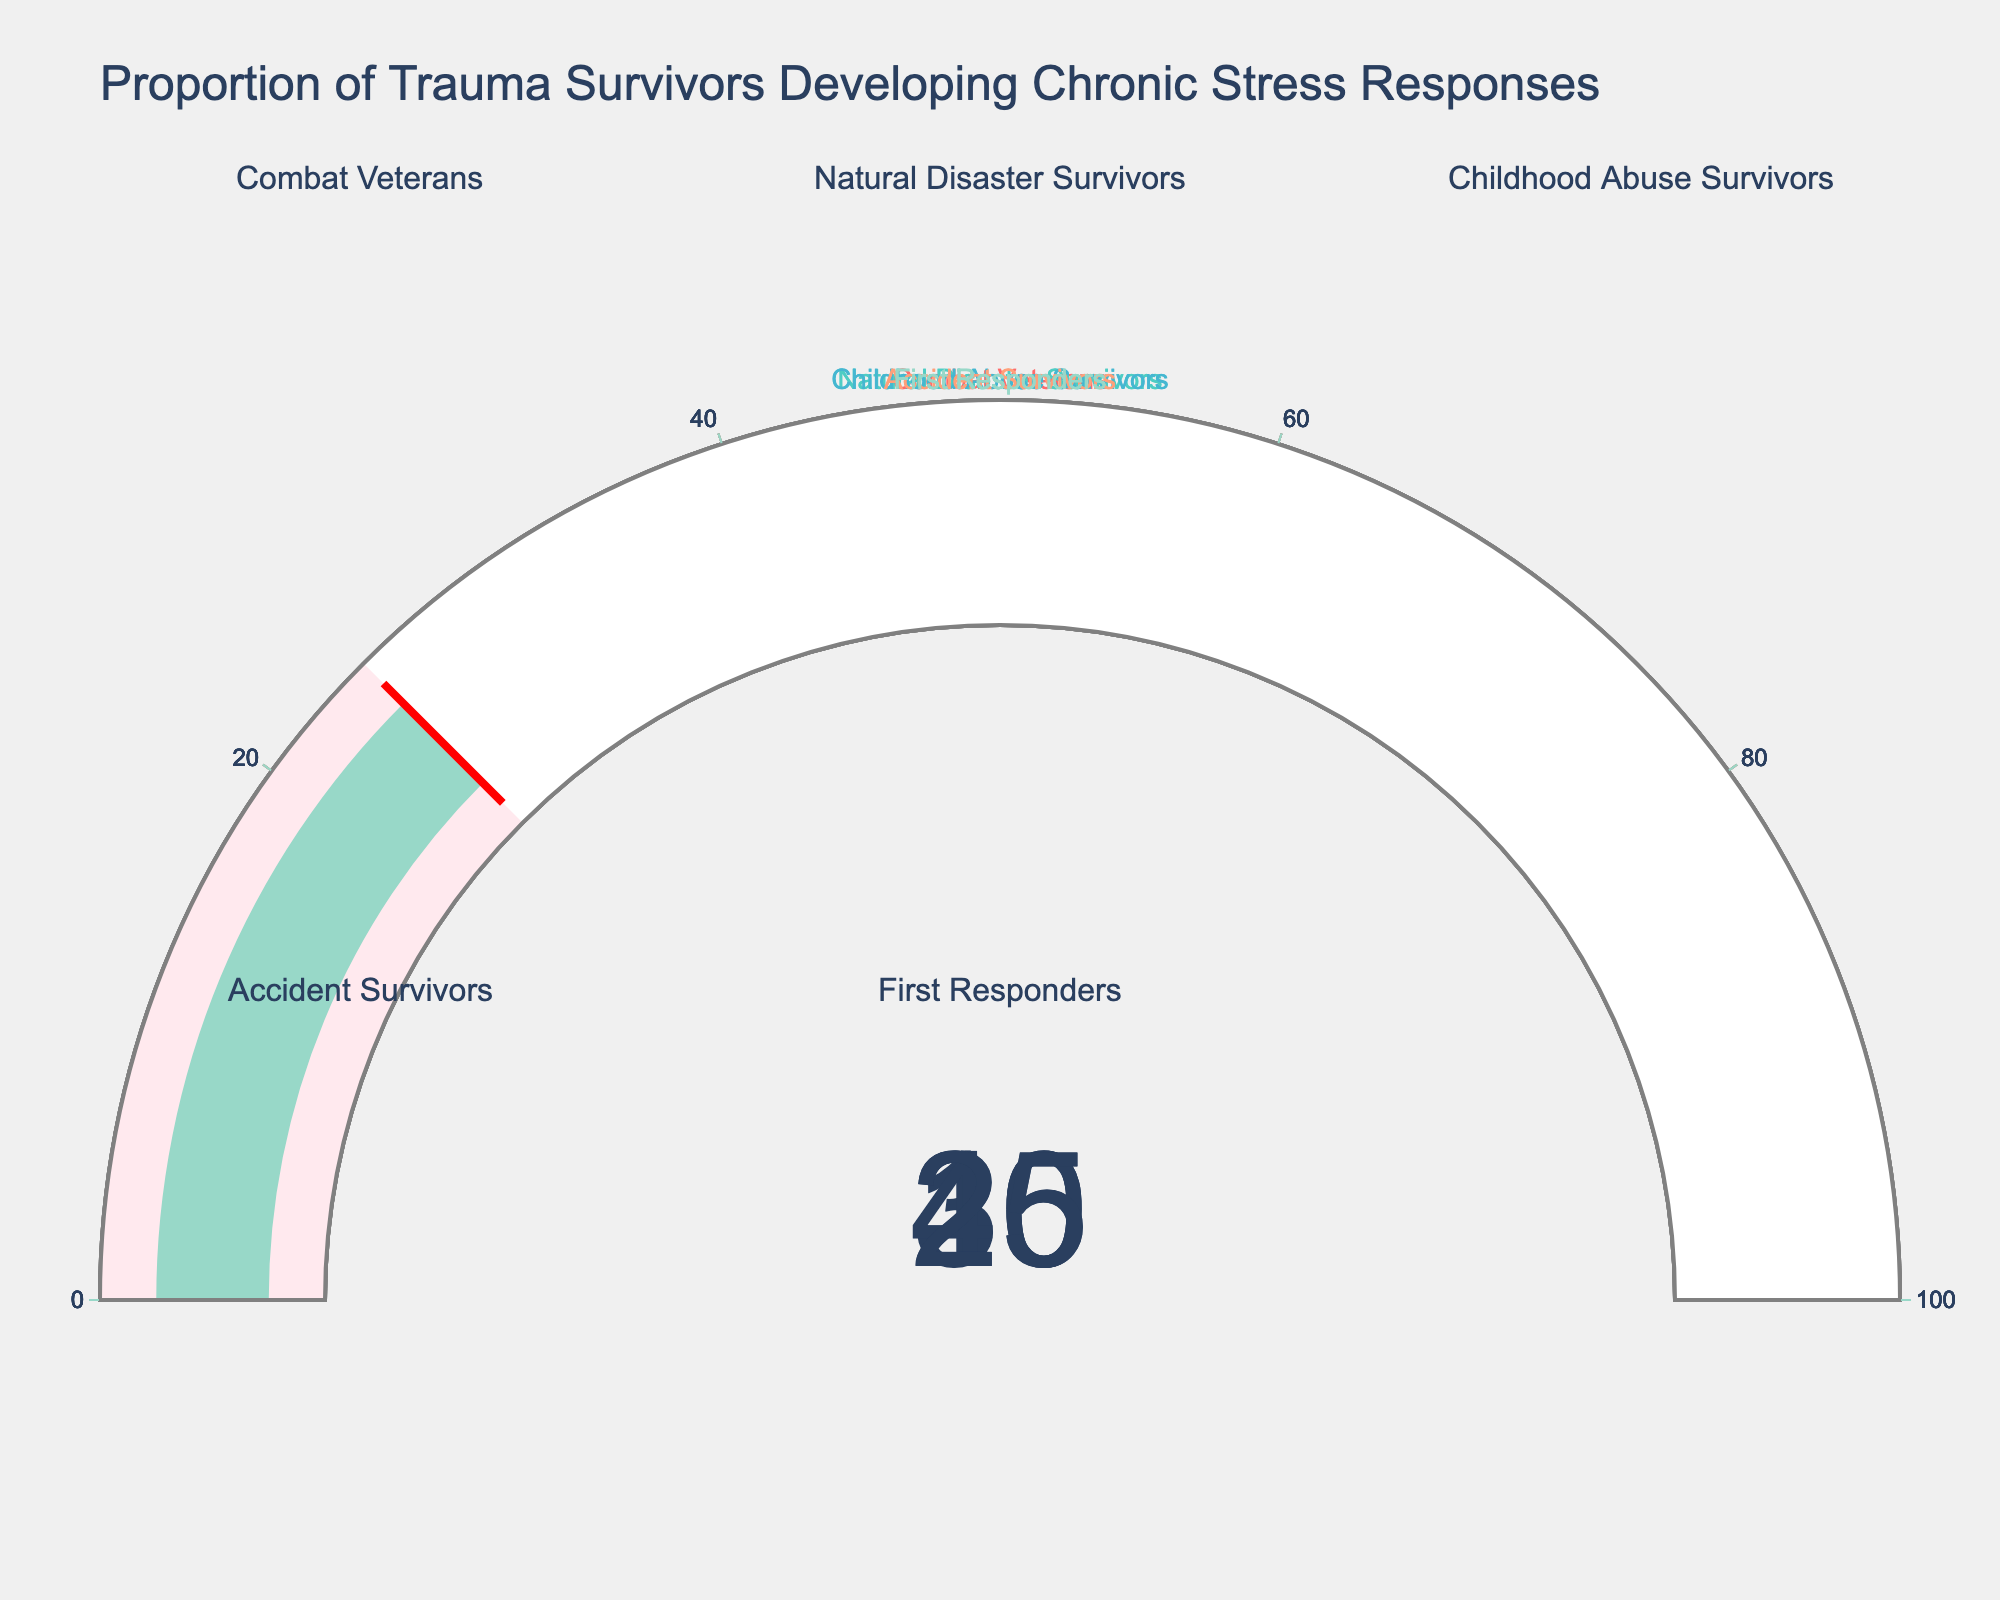What is the title of the figure? The title is located at the top of the figure and provides an overall description of the content. By reading the title text, we can identify it.
Answer: Proportion of Trauma Survivors Developing Chronic Stress Responses How many categories are displayed in the figure? By counting the number of individual gauge charts in the figure, we can determine the number of categories.
Answer: 5 Which category has the highest proportion of trauma survivors developing chronic stress responses? To find this, we compare the values displayed on each gauge chart. The highest value will indicate the category with the highest proportion.
Answer: Childhood Abuse Survivors What is the difference in percentage between Accident Survivors and First Responders? Identify the values for Accident Survivors (20%) and First Responders (25%). Subtract the smaller percentage from the larger one to find the difference.
Answer: 5% Which category has a lower proportion of chronic stress responses, Natural Disaster Survivors or Combat Veterans? By comparing the values for Natural Disaster Survivors (15%) and Combat Veterans (30%), we can see which is lower.
Answer: Natural Disaster Survivors Calculate the average proportion of chronic stress responses across all categories. Sum the percentages (30 + 15 + 40 + 20 + 25 = 130) and divide by the number of categories (5) to find the average.
Answer: 26% If you combine the percentages of Natural Disaster Survivors and Accident Survivors, does it exceed the percentage for Childhood Abuse Survivors? Add the percentages of Natural Disaster Survivors (15%) and Accident Survivors (20%) and compare the sum (35%) to the percentage for Childhood Abuse Survivors (40%).
Answer: No Which category has a percentage closest to the median value of the overall percentages? List the percentages in ascending order (15, 20, 25, 30, 40) and find the middle value (25%), which is the median. Identify that First Responders also have 25%.
Answer: First Responders 